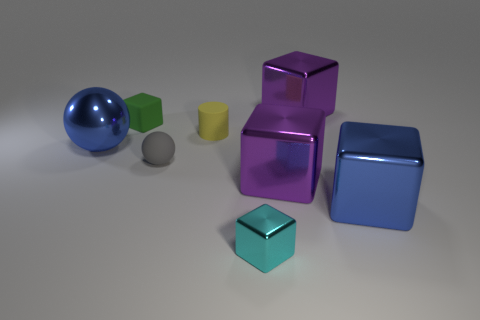Do the gray ball and the purple object in front of the yellow rubber thing have the same size?
Your answer should be very brief. No. There is a large shiny thing on the left side of the large purple thing that is in front of the small green matte cube; what is its color?
Ensure brevity in your answer.  Blue. Are there an equal number of small rubber blocks that are to the right of the cylinder and purple blocks behind the large blue metallic sphere?
Keep it short and to the point. No. Do the big cube behind the green cube and the gray sphere have the same material?
Offer a terse response. No. What is the color of the object that is both on the right side of the tiny yellow thing and behind the tiny yellow rubber cylinder?
Offer a very short reply. Purple. There is a large cube that is behind the small cylinder; what number of large metallic spheres are on the left side of it?
Provide a short and direct response. 1. There is another large thing that is the same shape as the gray rubber object; what is it made of?
Ensure brevity in your answer.  Metal. What color is the rubber cube?
Keep it short and to the point. Green. What number of objects are small gray things or large cyan things?
Offer a terse response. 1. There is a rubber thing in front of the large thing on the left side of the small cylinder; what is its shape?
Offer a very short reply. Sphere. 